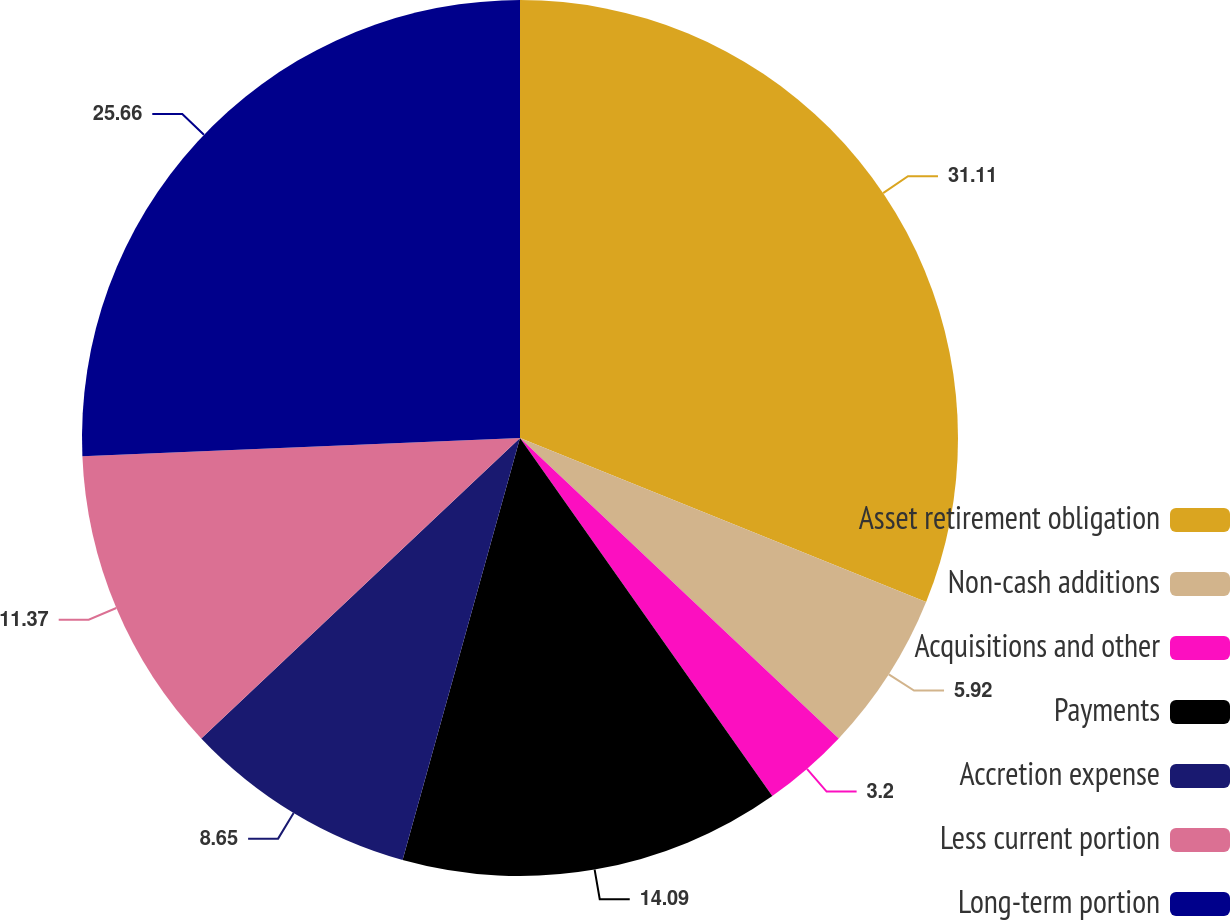<chart> <loc_0><loc_0><loc_500><loc_500><pie_chart><fcel>Asset retirement obligation<fcel>Non-cash additions<fcel>Acquisitions and other<fcel>Payments<fcel>Accretion expense<fcel>Less current portion<fcel>Long-term portion<nl><fcel>31.11%<fcel>5.92%<fcel>3.2%<fcel>14.09%<fcel>8.65%<fcel>11.37%<fcel>25.66%<nl></chart> 